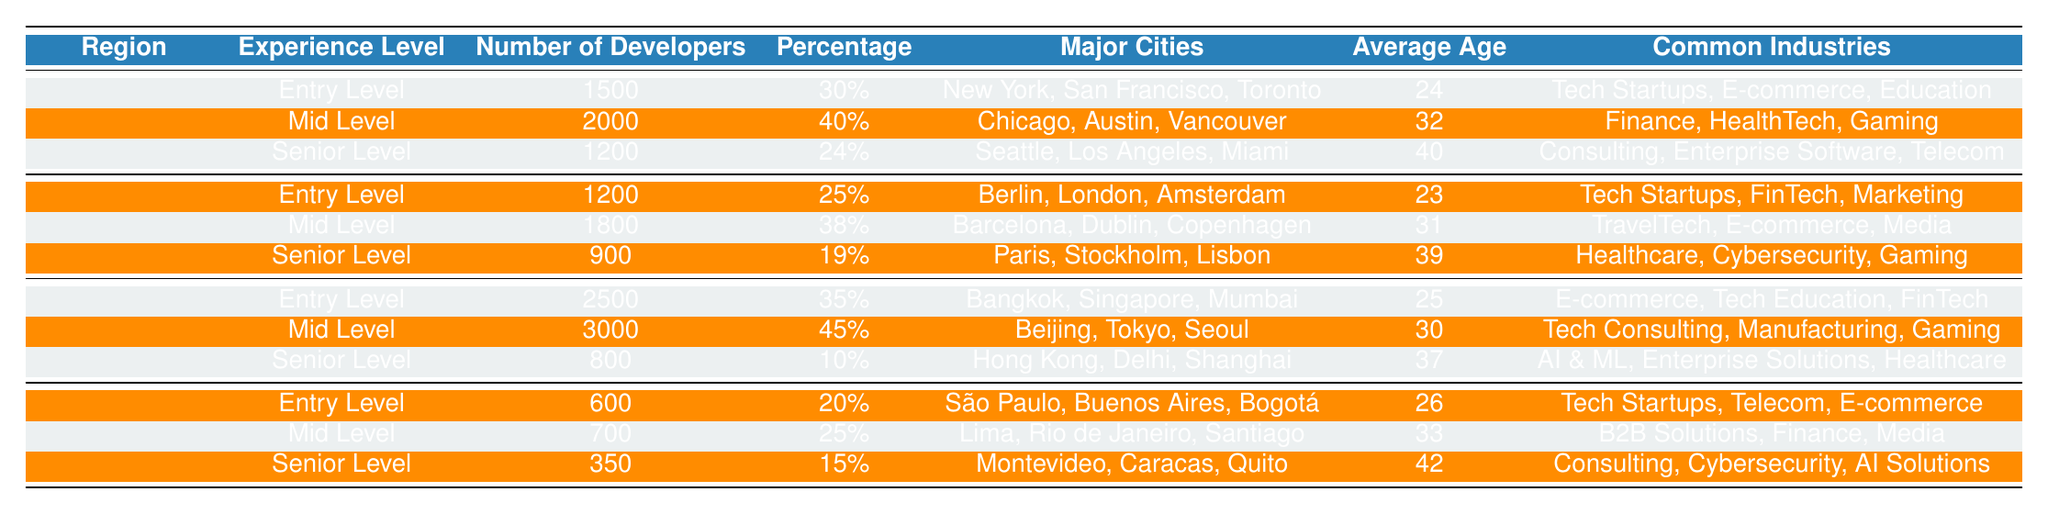What is the total number of entry-level Django developers across all regions? To find the total number of entry-level developers, we can add the numbers from each region: North America (1500) + Europe (1200) + Asia (2500) + South America (600) = 4800.
Answer: 4800 What percentage of developers in Asia are of mid-level experience? The data shows that there are 3000 mid-level developers in Asia and the total number of developers in Asia is 2500 (entry-level) + 3000 (mid-level) + 800 (senior-level) = 6300. Therefore, the percentage of mid-level developers is (3000/6300) * 100 = 47.62%.
Answer: 45% Which region has the highest average age for senior-level developers? By comparing the average ages of senior-level developers: North America (40), Europe (39), Asia (37), and South America (42), South America has the highest average age at 42.
Answer: South America What are the common industries for mid-level developers in Europe? The table lists the common industries for mid-level developers in Europe as TravelTech, E-commerce, and Media.
Answer: TravelTech, E-commerce, Media Is there a higher percentage of entry-level developers in North America compared to South America? North America has 30% entry-level developers, while South America has only 20%, so North America does have a higher percentage.
Answer: Yes What is the difference in the number of senior-level developers between North America and Asia? The number of senior-level developers in North America is 1200 and in Asia, it is 800. The difference is 1200 - 800 = 400.
Answer: 400 In which major city is the entry-level developer population the highest, and what is that population? In Asia, the entry-level developer population is the highest with 2500 developers based in cities like Bangkok, Singapore, and Mumbai.
Answer: 2500 What is the total percentage of developers categorized as mid-level in Europe and South America combined? The mid-level percentages are 38% for Europe and 25% for South America. Adding these gives 38 + 25 = 63%.
Answer: 63% What is the average age of entry-level developers across all regions? The average ages for entry-level developers are North America (24), Europe (23), Asia (25), and South America (26). Adding these gives 24 + 23 + 25 + 26 = 98. Dividing by 4 (the number of regions) gives an average age of 24.5.
Answer: 24.5 In which region do mid-level developers have the lowest number of developers? The mid-level developers in South America total 700, which is lower than North America (2000), Europe (1800), and Asia (3000).
Answer: South America 